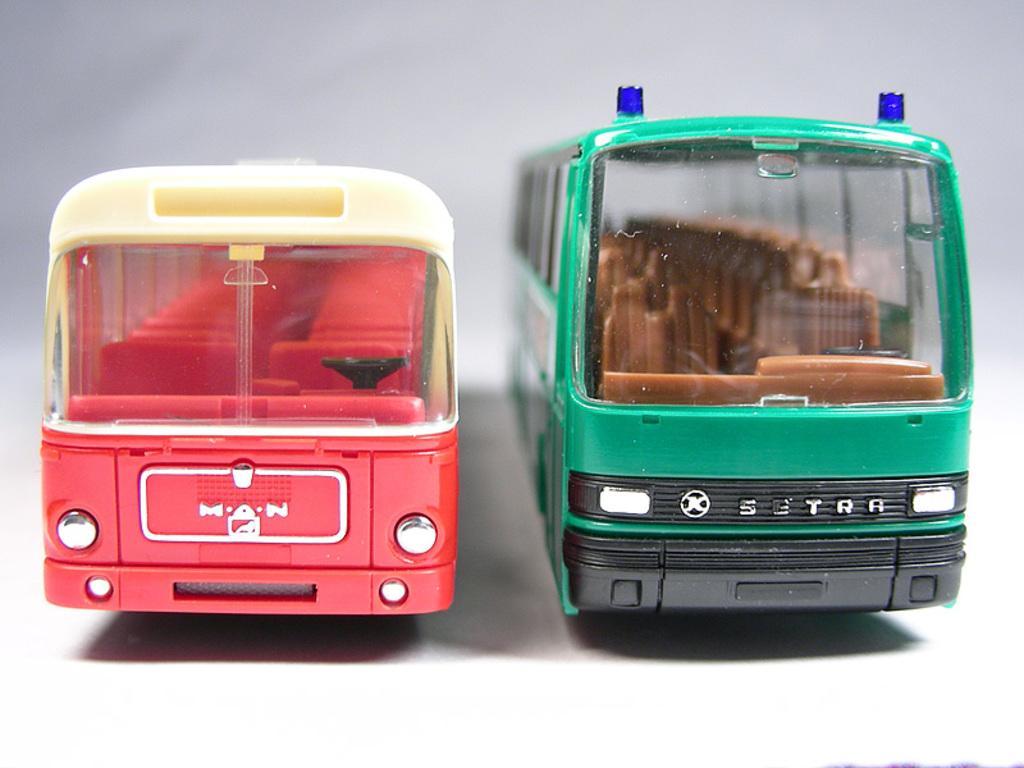Can you describe this image briefly? In the center of the image we can see toy buses. 